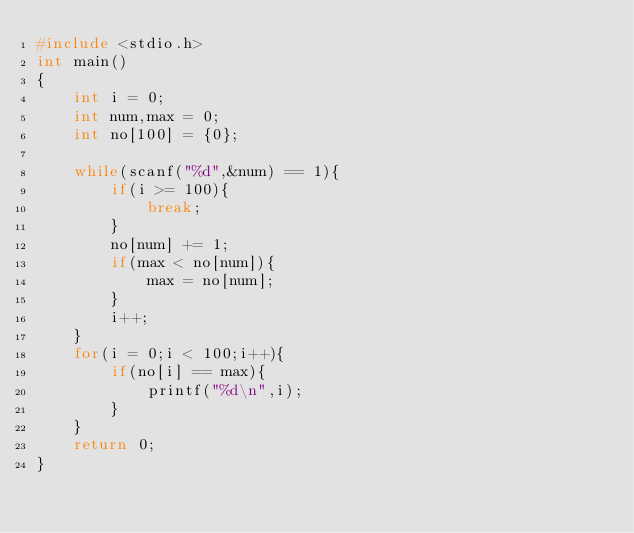Convert code to text. <code><loc_0><loc_0><loc_500><loc_500><_C_>#include <stdio.h>
int main()
{
    int i = 0;
    int num,max = 0;
    int no[100] = {0};
    
    while(scanf("%d",&num) == 1){
        if(i >= 100){
            break;
        }
        no[num] += 1;
        if(max < no[num]){
            max = no[num];
        }
        i++;
    }
    for(i = 0;i < 100;i++){
        if(no[i] == max){
            printf("%d\n",i);
        }
    }
    return 0;
}</code> 